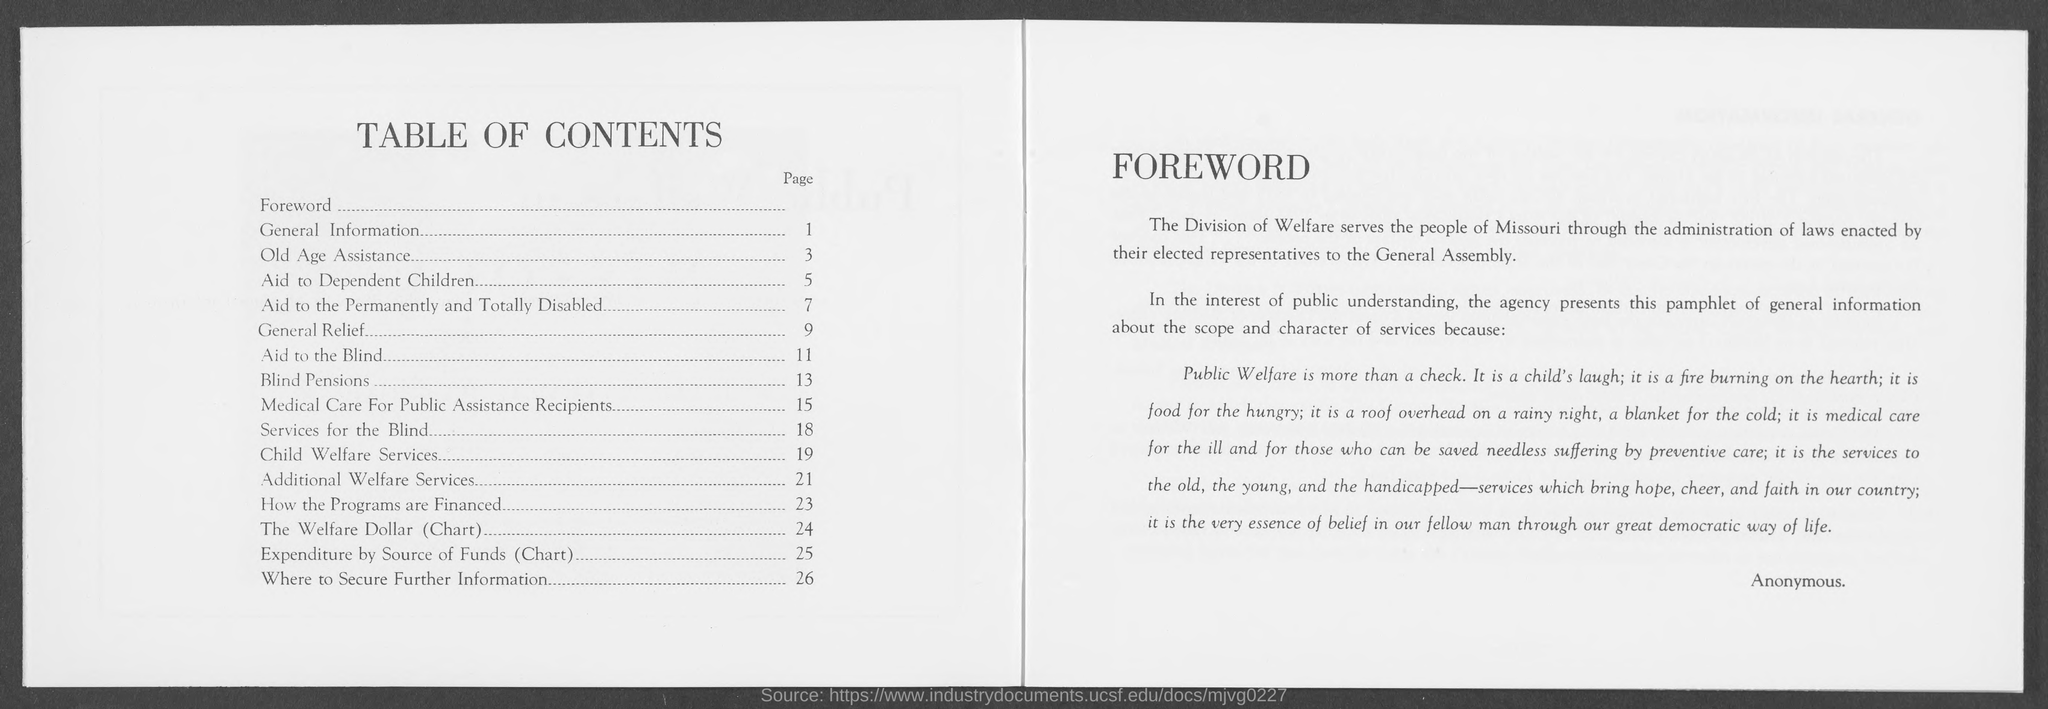Mention a couple of crucial points in this snapshot. The page number for General Relief is 9. The page number for Aid to Dependent Children is five. What is the page number for General Information? 1.." can be converted to "The page number for General Information is 1.. The page number for Services for the Blind is 18. The page number for Old Age assistance is 3. 